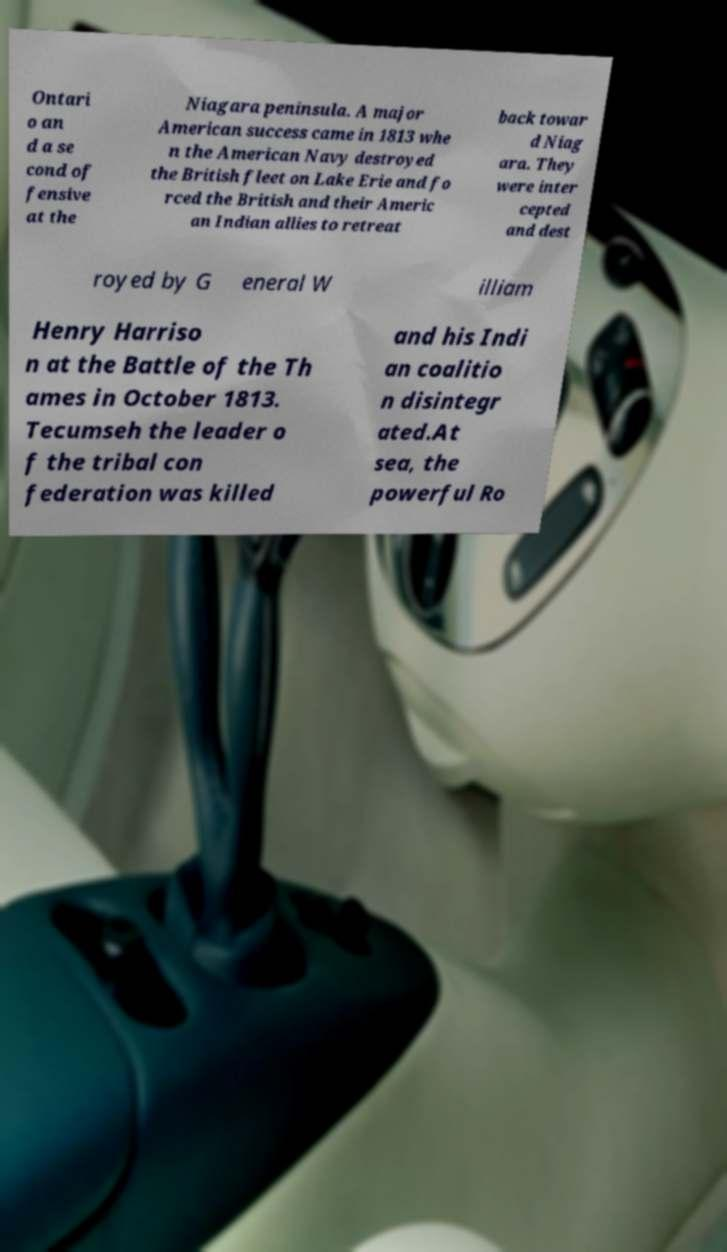Could you assist in decoding the text presented in this image and type it out clearly? Ontari o an d a se cond of fensive at the Niagara peninsula. A major American success came in 1813 whe n the American Navy destroyed the British fleet on Lake Erie and fo rced the British and their Americ an Indian allies to retreat back towar d Niag ara. They were inter cepted and dest royed by G eneral W illiam Henry Harriso n at the Battle of the Th ames in October 1813. Tecumseh the leader o f the tribal con federation was killed and his Indi an coalitio n disintegr ated.At sea, the powerful Ro 